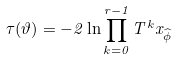<formula> <loc_0><loc_0><loc_500><loc_500>\tau ( \vartheta ) = - 2 \ln \prod _ { k = 0 } ^ { r - 1 } T ^ { k } x _ { \widehat { \phi } }</formula> 